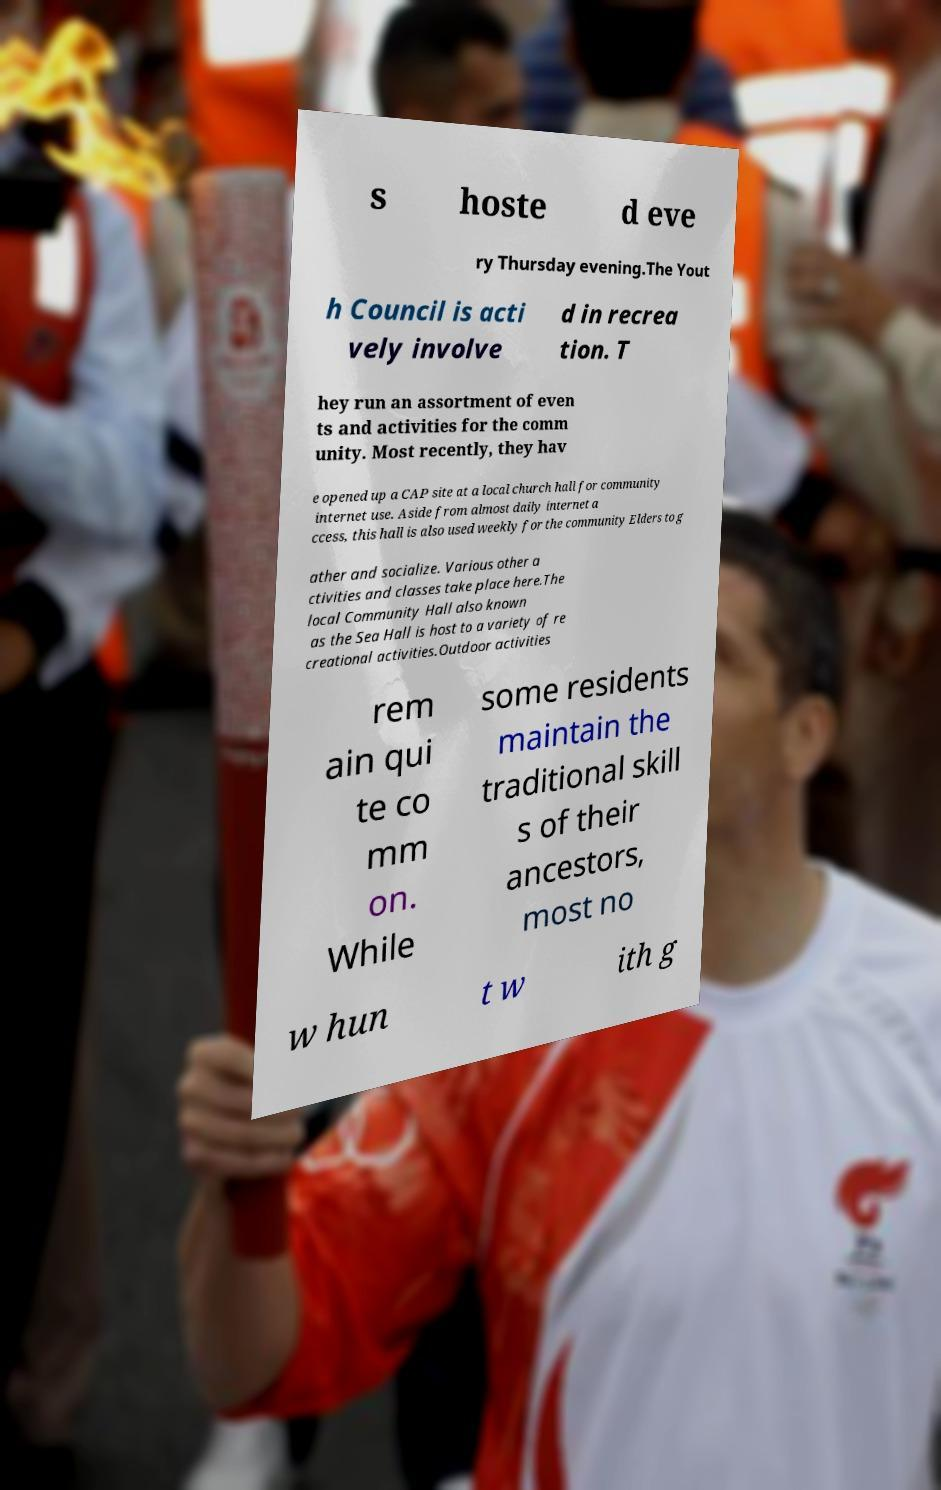Could you assist in decoding the text presented in this image and type it out clearly? s hoste d eve ry Thursday evening.The Yout h Council is acti vely involve d in recrea tion. T hey run an assortment of even ts and activities for the comm unity. Most recently, they hav e opened up a CAP site at a local church hall for community internet use. Aside from almost daily internet a ccess, this hall is also used weekly for the community Elders to g ather and socialize. Various other a ctivities and classes take place here.The local Community Hall also known as the Sea Hall is host to a variety of re creational activities.Outdoor activities rem ain qui te co mm on. While some residents maintain the traditional skill s of their ancestors, most no w hun t w ith g 